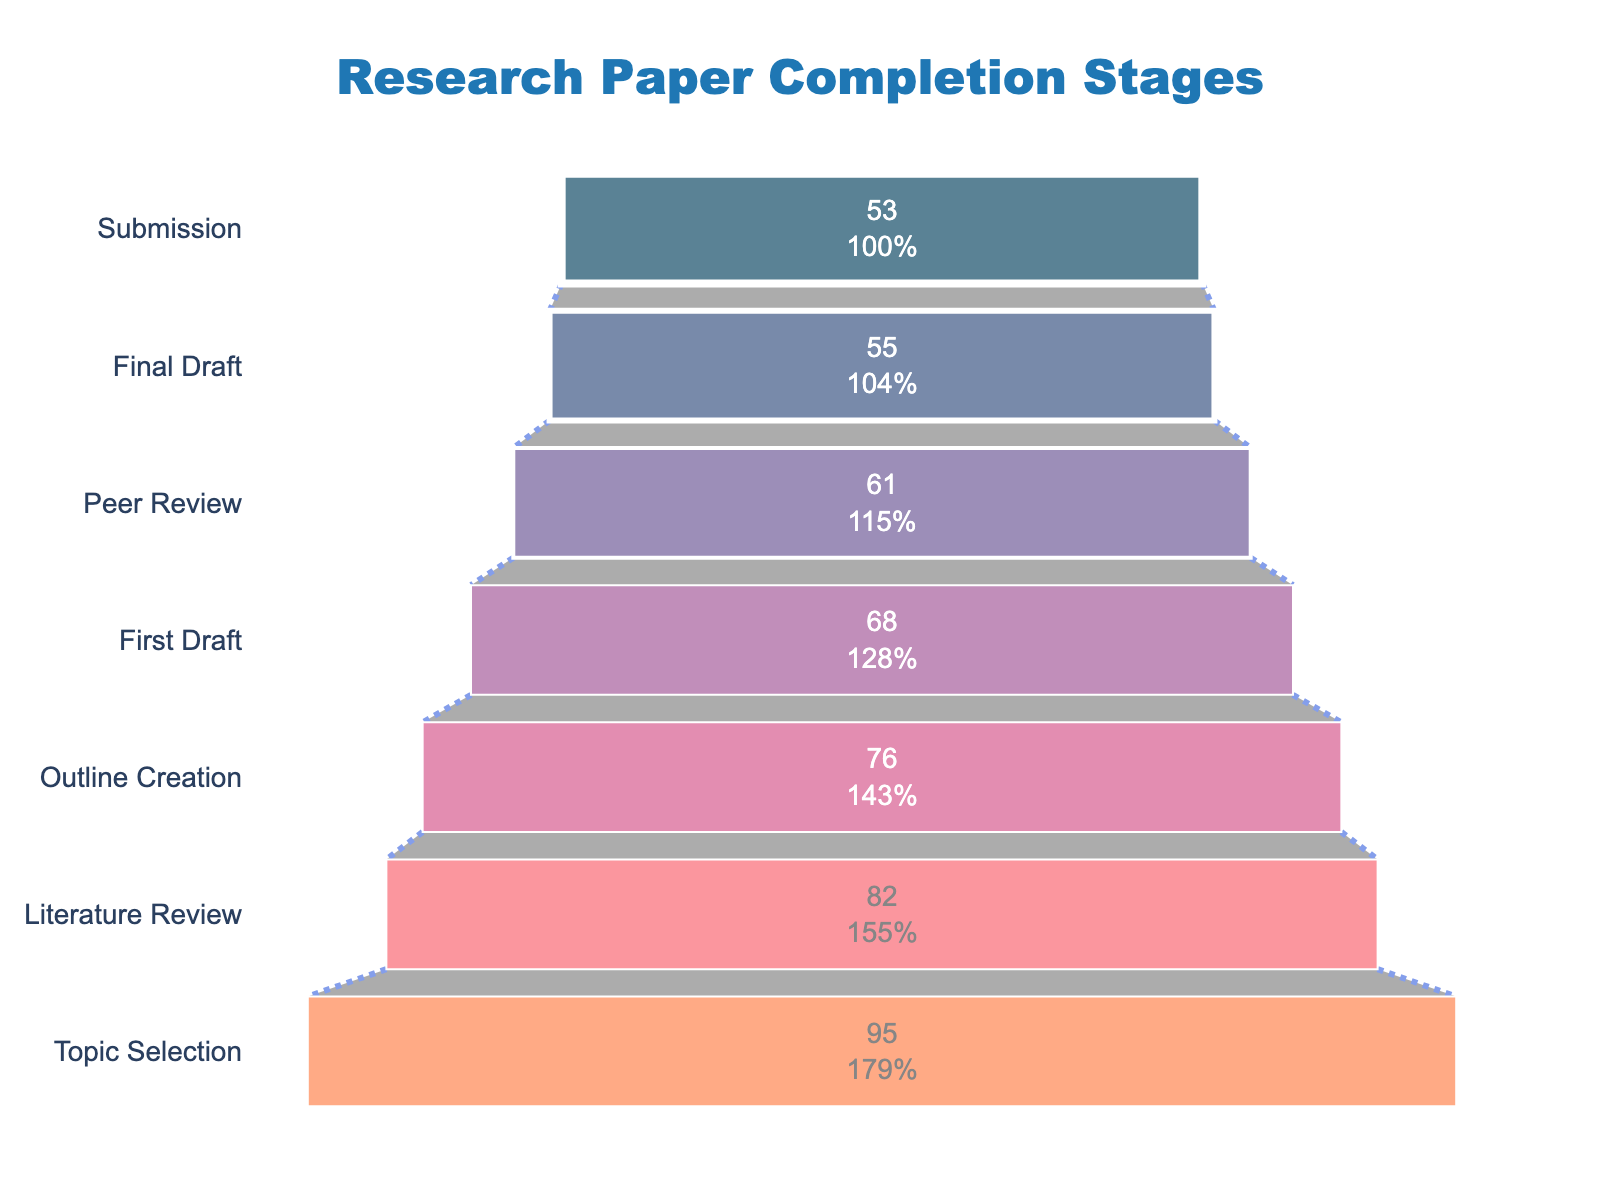What is the title of the Funnel Chart? The title is displayed at the top center of the figure. It reads "Research Paper Completion Stages".
Answer: Research Paper Completion Stages How many stages are displayed in the funnel chart? Each stage is represented by a funnel bar. There are seven stages represented in the chart.
Answer: Seven Which stage has the highest number of students? The topmost bar represents the highest number of students, which is "Topic Selection" with 95 students.
Answer: Topic Selection What is the percentage of students who submitted their final draft? The final draft submission bar shows both the number (55) and percentage. The percentage of students who reached the final draft stage is displayed directly on the bar, which is 57.9%.
Answer: 57.9% What is the difference in the number of students between "Literature Review" and "First Draft"? Subtract the number of students at the "First Draft" stage from the number at the "Literature Review" stage: 82 - 68 = 14 students.
Answer: 14 students How many students moved from the "Outline Creation" stage to the "Final Draft" stage? First, note the number of students at the "Outline Creation" stage (76) and those at the "Final Draft" stage (55). By subtracting the latter from the former, we get the number of students who dropped off between these stages: 76 - 55 = 21 students.
Answer: 21 students Which stage had the largest drop in student numbers from the previous stage? By comparing the difference in student numbers between consecutive stages, the largest drop is from "Topic Selection" (95) to "Literature Review" (82): 95 - 82 = 13 students.
Answer: From Topic Selection to Literature Review What percentage of the initial students reached the "Submission" stage? The "Submission" stage is represented by the last bar, showing 53 students. The percentage is displayed directly on the bar: 55.8%.
Answer: 55.8% On average, how many students left after each stage? Find the total loss of students from the initial stage to the final stage by subtracting the final number from the initial number: 95 - 53 = 42 students. Divide this loss by the number of transitions (6 transitions): 42/6 = 7 students per stage.
Answer: 7 students per stage How does the height of the funnel bars help to understand data progression? In a funnel chart, the height of each bar is proportional to the number of students remaining at each stage. As each stage progresses, the height usually reduces, illustrating the dropout rate visually.
Answer: Helps illustrate dropout rate 